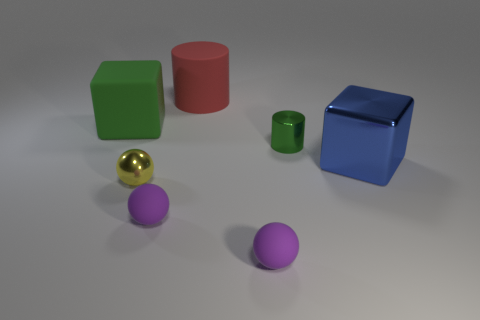Add 2 blocks. How many objects exist? 9 Subtract all cubes. How many objects are left? 5 Add 4 cylinders. How many cylinders are left? 6 Add 1 red rubber cylinders. How many red rubber cylinders exist? 2 Subtract 0 blue spheres. How many objects are left? 7 Subtract all large green matte cubes. Subtract all small purple rubber things. How many objects are left? 4 